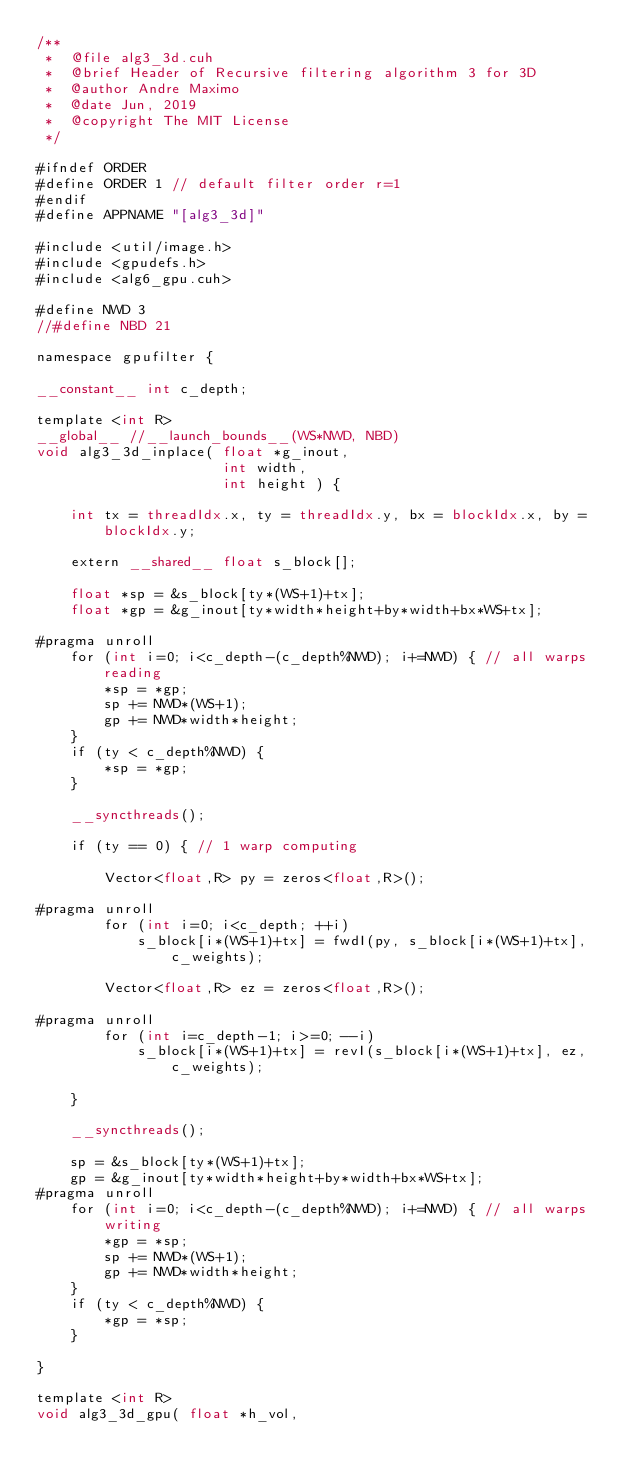<code> <loc_0><loc_0><loc_500><loc_500><_Cuda_>/**
 *  @file alg3_3d.cuh
 *  @brief Header of Recursive filtering algorithm 3 for 3D
 *  @author Andre Maximo
 *  @date Jun, 2019
 *  @copyright The MIT License
 */

#ifndef ORDER
#define ORDER 1 // default filter order r=1
#endif
#define APPNAME "[alg3_3d]"

#include <util/image.h>
#include <gpudefs.h>
#include <alg6_gpu.cuh>

#define NWD 3
//#define NBD 21

namespace gpufilter {

__constant__ int c_depth;

template <int R>
__global__ //__launch_bounds__(WS*NWD, NBD)
void alg3_3d_inplace( float *g_inout,
                      int width,
                      int height ) {

    int tx = threadIdx.x, ty = threadIdx.y, bx = blockIdx.x, by = blockIdx.y;

    extern __shared__ float s_block[];

    float *sp = &s_block[ty*(WS+1)+tx];
    float *gp = &g_inout[ty*width*height+by*width+bx*WS+tx];

#pragma unroll
    for (int i=0; i<c_depth-(c_depth%NWD); i+=NWD) { // all warps reading
        *sp = *gp;
        sp += NWD*(WS+1);
        gp += NWD*width*height;
    }
    if (ty < c_depth%NWD) {
        *sp = *gp;
    }

    __syncthreads();

    if (ty == 0) { // 1 warp computing

        Vector<float,R> py = zeros<float,R>();

#pragma unroll
        for (int i=0; i<c_depth; ++i)
            s_block[i*(WS+1)+tx] = fwdI(py, s_block[i*(WS+1)+tx], c_weights);

        Vector<float,R> ez = zeros<float,R>();

#pragma unroll
        for (int i=c_depth-1; i>=0; --i)
            s_block[i*(WS+1)+tx] = revI(s_block[i*(WS+1)+tx], ez, c_weights);

    }

    __syncthreads();

    sp = &s_block[ty*(WS+1)+tx];
    gp = &g_inout[ty*width*height+by*width+bx*WS+tx];
#pragma unroll
    for (int i=0; i<c_depth-(c_depth%NWD); i+=NWD) { // all warps writing
        *gp = *sp;
        sp += NWD*(WS+1);
        gp += NWD*width*height;
    }
    if (ty < c_depth%NWD) {
        *gp = *sp;
    }

}

template <int R>
void alg3_3d_gpu( float *h_vol,</code> 